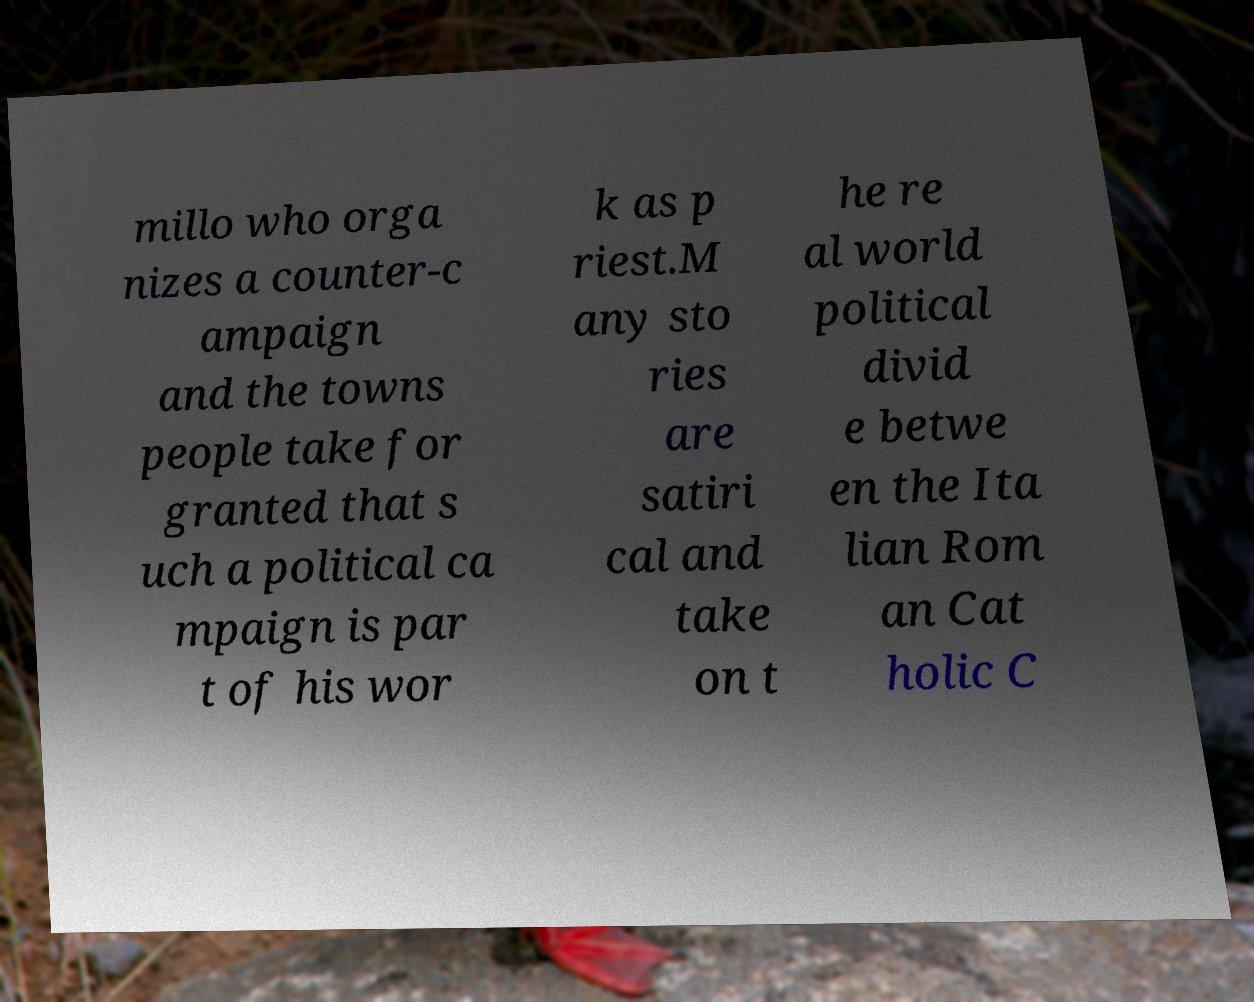Can you read and provide the text displayed in the image?This photo seems to have some interesting text. Can you extract and type it out for me? millo who orga nizes a counter-c ampaign and the towns people take for granted that s uch a political ca mpaign is par t of his wor k as p riest.M any sto ries are satiri cal and take on t he re al world political divid e betwe en the Ita lian Rom an Cat holic C 